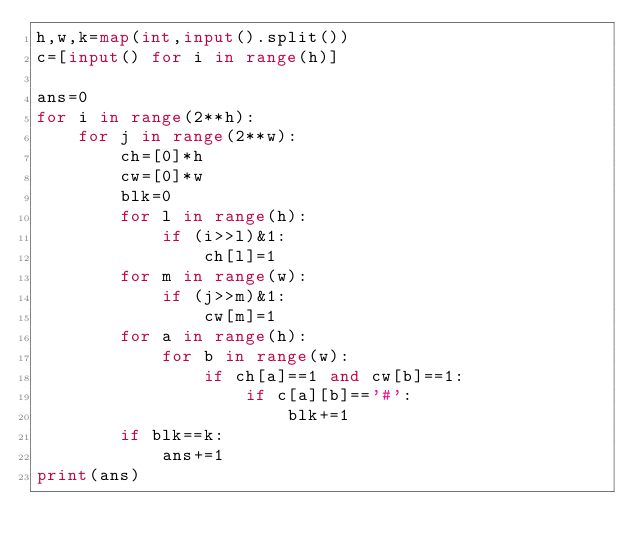Convert code to text. <code><loc_0><loc_0><loc_500><loc_500><_Python_>h,w,k=map(int,input().split())
c=[input() for i in range(h)]

ans=0
for i in range(2**h):
    for j in range(2**w):
        ch=[0]*h
        cw=[0]*w
        blk=0
        for l in range(h):
            if (i>>l)&1:
                ch[l]=1
        for m in range(w):
            if (j>>m)&1:
                cw[m]=1
        for a in range(h):
            for b in range(w):
                if ch[a]==1 and cw[b]==1:
                    if c[a][b]=='#':
                        blk+=1
        if blk==k:
            ans+=1
print(ans)</code> 